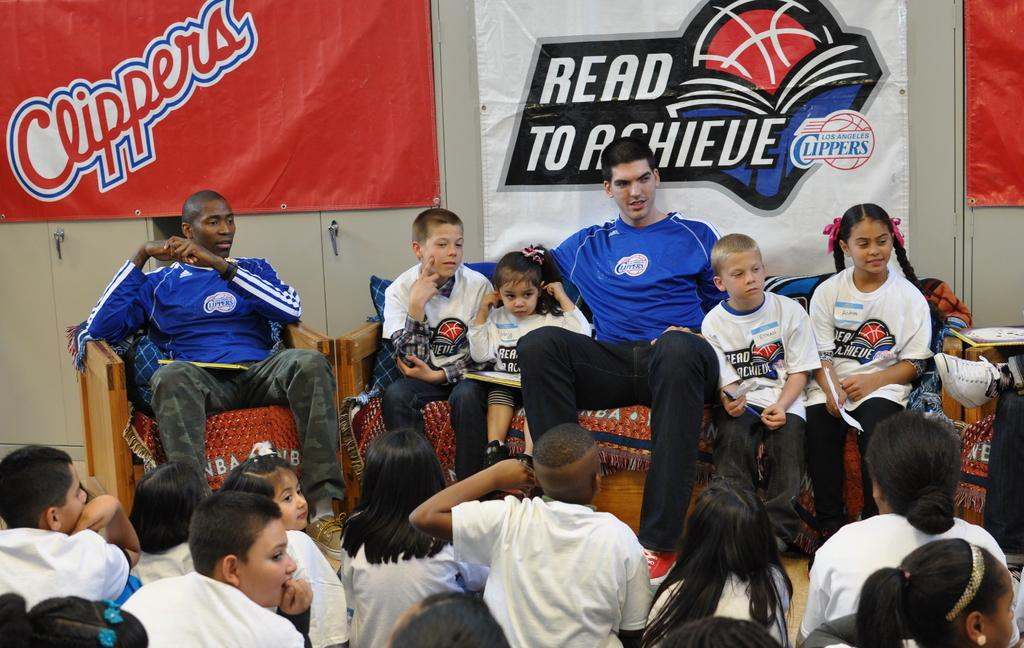<image>
Describe the image concisely. A group of clipper fans gathered together for a read to achieve group. 